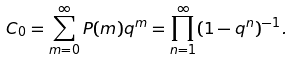<formula> <loc_0><loc_0><loc_500><loc_500>C _ { 0 } = \sum _ { m = 0 } ^ { \infty } P ( m ) q ^ { m } = \prod _ { n = 1 } ^ { \infty } ( 1 - q ^ { n } ) ^ { - 1 } .</formula> 